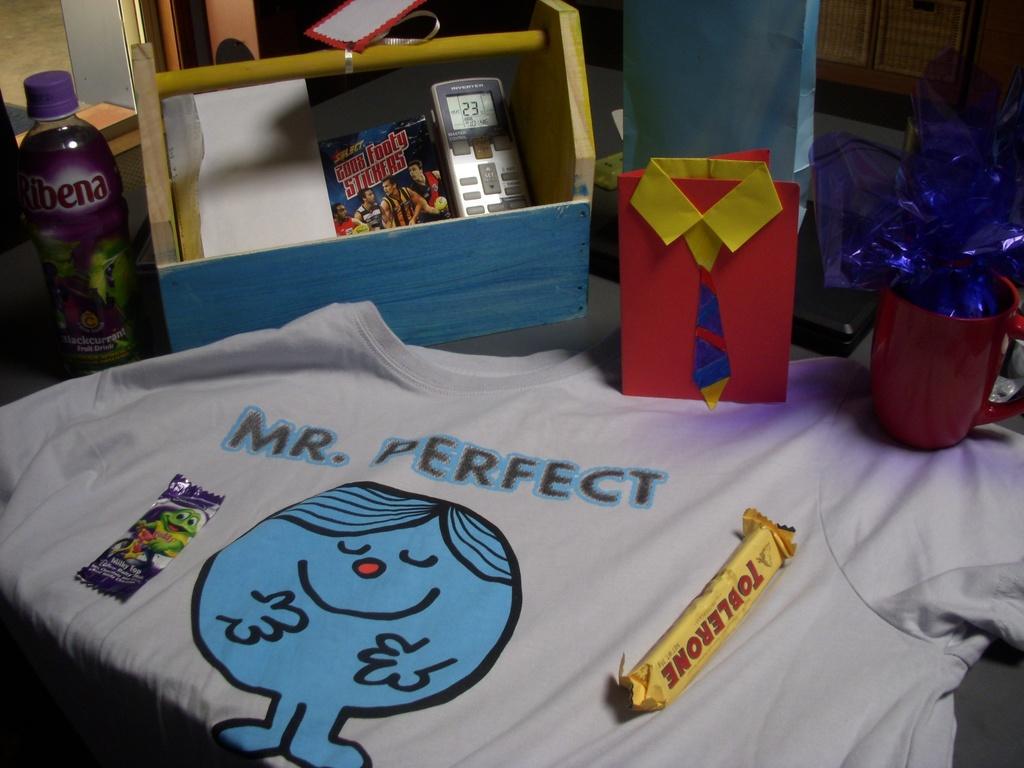What does the shirt say?
Provide a succinct answer. Mr. perfect. What kind of candy bar is on the t shirt?
Ensure brevity in your answer.  Toblerone. 